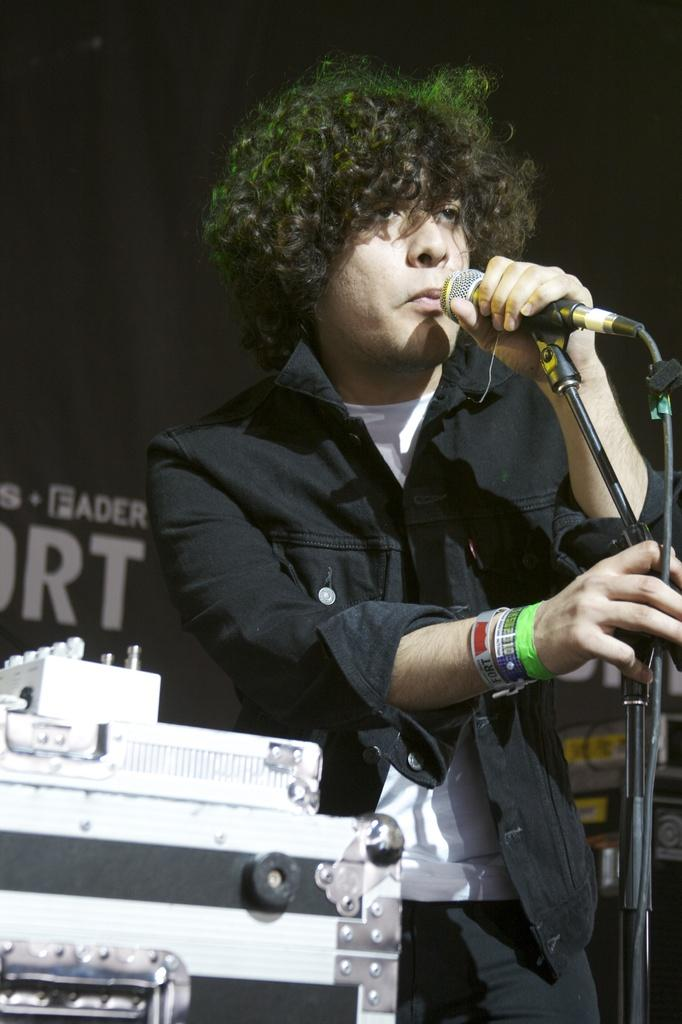Who is present in the image? There is a man in the image. What is the man holding in the image? The man is holding a mic. What is the man's posture in the image? The man is standing. What else can be seen in the image besides the man? There is equipment visible in the image. How many boys are teaching in the image? There are no boys present in the image, and no one is teaching. 